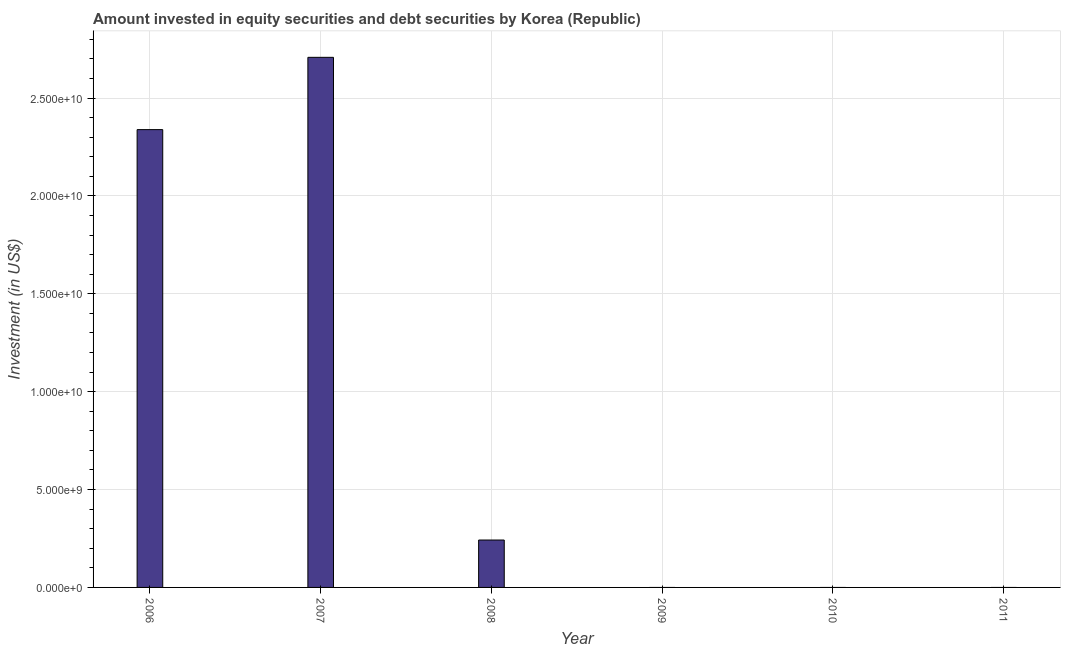What is the title of the graph?
Ensure brevity in your answer.  Amount invested in equity securities and debt securities by Korea (Republic). What is the label or title of the Y-axis?
Your answer should be very brief. Investment (in US$). What is the portfolio investment in 2008?
Provide a short and direct response. 2.42e+09. Across all years, what is the maximum portfolio investment?
Offer a terse response. 2.71e+1. Across all years, what is the minimum portfolio investment?
Your answer should be very brief. 0. In which year was the portfolio investment maximum?
Provide a short and direct response. 2007. What is the sum of the portfolio investment?
Make the answer very short. 5.29e+1. What is the difference between the portfolio investment in 2007 and 2008?
Offer a very short reply. 2.47e+1. What is the average portfolio investment per year?
Provide a short and direct response. 8.81e+09. What is the median portfolio investment?
Make the answer very short. 1.21e+09. In how many years, is the portfolio investment greater than 6000000000 US$?
Offer a terse response. 2. What is the ratio of the portfolio investment in 2007 to that in 2008?
Give a very brief answer. 11.18. Is the difference between the portfolio investment in 2007 and 2008 greater than the difference between any two years?
Offer a terse response. No. What is the difference between the highest and the second highest portfolio investment?
Give a very brief answer. 3.69e+09. Is the sum of the portfolio investment in 2007 and 2008 greater than the maximum portfolio investment across all years?
Make the answer very short. Yes. What is the difference between the highest and the lowest portfolio investment?
Keep it short and to the point. 2.71e+1. Are all the bars in the graph horizontal?
Provide a succinct answer. No. What is the difference between two consecutive major ticks on the Y-axis?
Keep it short and to the point. 5.00e+09. Are the values on the major ticks of Y-axis written in scientific E-notation?
Provide a succinct answer. Yes. What is the Investment (in US$) of 2006?
Offer a very short reply. 2.34e+1. What is the Investment (in US$) in 2007?
Offer a terse response. 2.71e+1. What is the Investment (in US$) in 2008?
Offer a very short reply. 2.42e+09. What is the Investment (in US$) in 2011?
Give a very brief answer. 0. What is the difference between the Investment (in US$) in 2006 and 2007?
Make the answer very short. -3.69e+09. What is the difference between the Investment (in US$) in 2006 and 2008?
Your answer should be compact. 2.10e+1. What is the difference between the Investment (in US$) in 2007 and 2008?
Give a very brief answer. 2.47e+1. What is the ratio of the Investment (in US$) in 2006 to that in 2007?
Offer a very short reply. 0.86. What is the ratio of the Investment (in US$) in 2006 to that in 2008?
Ensure brevity in your answer.  9.66. What is the ratio of the Investment (in US$) in 2007 to that in 2008?
Keep it short and to the point. 11.18. 